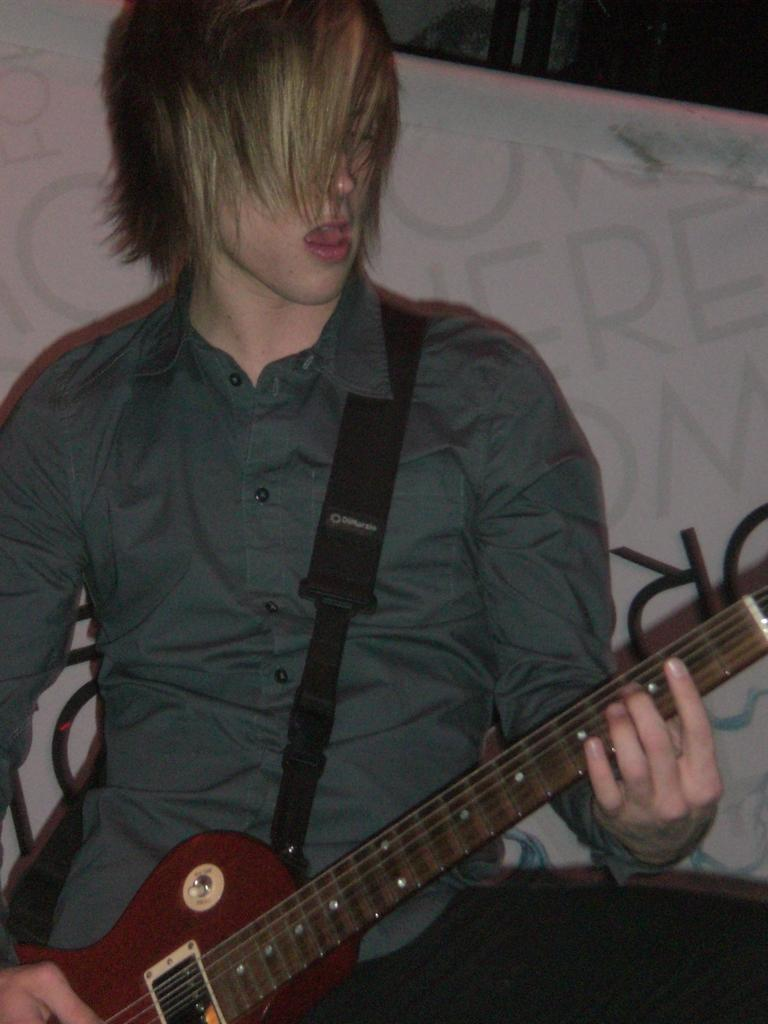What is present in the image? There is a person in the image. What is the person wearing? The person is wearing a shirt. What is the person holding? The person is holding a guitar. How many mice are visible on the tray in the image? There is no tray or mice present in the image. 